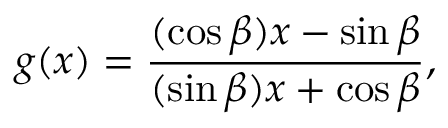Convert formula to latex. <formula><loc_0><loc_0><loc_500><loc_500>g ( x ) = { \frac { ( \cos \beta ) x - \sin \beta } { ( \sin \beta ) x + \cos \beta } } ,</formula> 